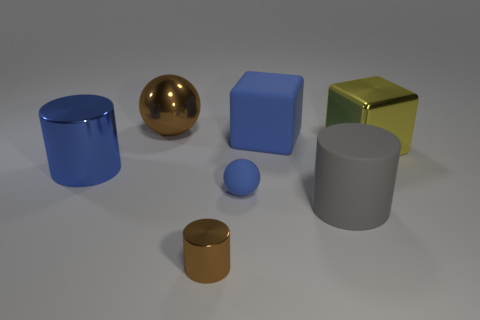There is another blue object that is the same size as the blue metal thing; what shape is it?
Ensure brevity in your answer.  Cube. How many other objects are there of the same color as the tiny cylinder?
Keep it short and to the point. 1. What is the color of the large cylinder in front of the blue shiny thing?
Give a very brief answer. Gray. How many other objects are there of the same material as the big ball?
Offer a terse response. 3. Are there more spheres left of the tiny brown shiny cylinder than metal spheres that are to the right of the large yellow object?
Make the answer very short. Yes. How many cylinders are right of the blue metallic object?
Offer a terse response. 2. Is the tiny brown cylinder made of the same material as the big block that is in front of the large blue matte block?
Offer a terse response. Yes. Does the gray cylinder have the same material as the blue sphere?
Your response must be concise. Yes. Is there a big rubber object that is to the right of the shiny cylinder on the right side of the brown shiny sphere?
Give a very brief answer. Yes. How many metal things are both on the left side of the matte cylinder and in front of the brown metal sphere?
Your answer should be very brief. 2. 